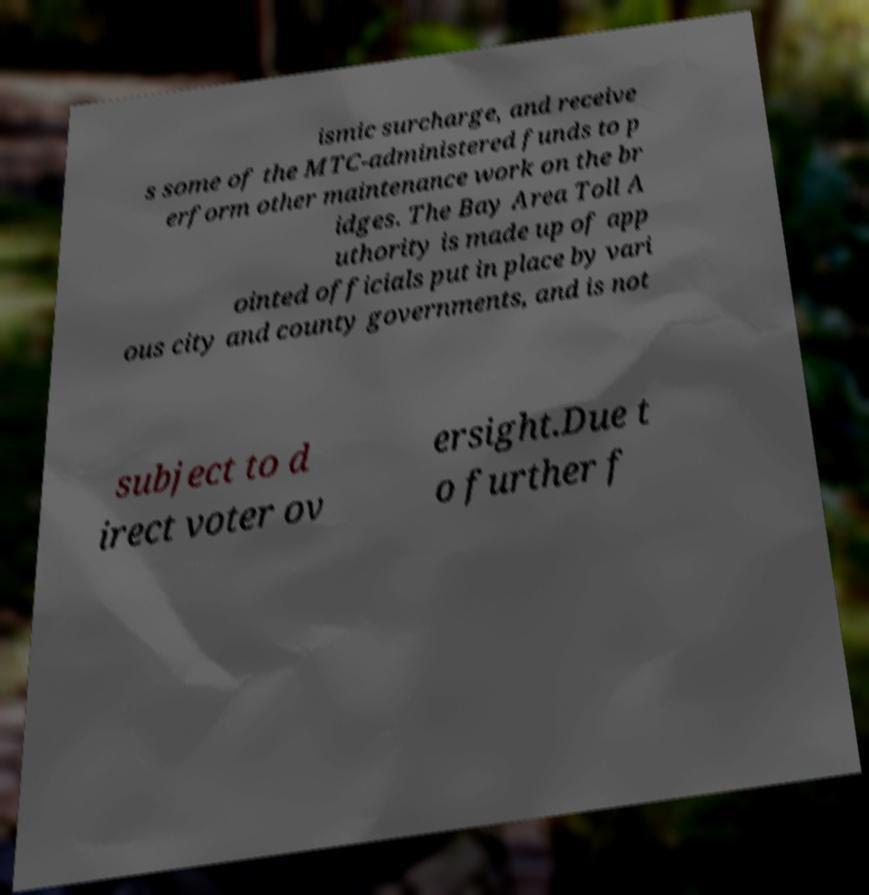Please identify and transcribe the text found in this image. ismic surcharge, and receive s some of the MTC-administered funds to p erform other maintenance work on the br idges. The Bay Area Toll A uthority is made up of app ointed officials put in place by vari ous city and county governments, and is not subject to d irect voter ov ersight.Due t o further f 